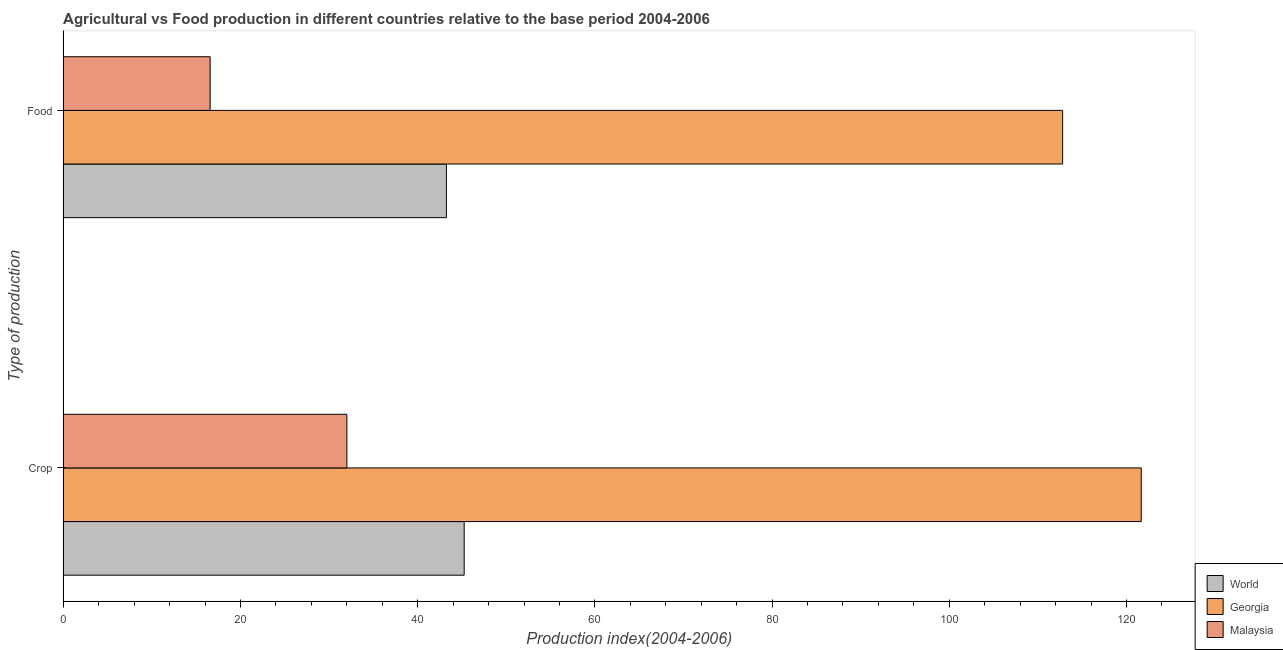Are the number of bars on each tick of the Y-axis equal?
Keep it short and to the point. Yes. How many bars are there on the 2nd tick from the top?
Your answer should be compact. 3. What is the label of the 1st group of bars from the top?
Ensure brevity in your answer.  Food. What is the crop production index in Georgia?
Keep it short and to the point. 121.66. Across all countries, what is the maximum crop production index?
Ensure brevity in your answer.  121.66. Across all countries, what is the minimum food production index?
Offer a very short reply. 16.58. In which country was the food production index maximum?
Provide a succinct answer. Georgia. In which country was the crop production index minimum?
Provide a succinct answer. Malaysia. What is the total crop production index in the graph?
Ensure brevity in your answer.  198.92. What is the difference between the crop production index in Georgia and that in Malaysia?
Your answer should be very brief. 89.65. What is the difference between the food production index in World and the crop production index in Georgia?
Offer a very short reply. -78.42. What is the average food production index per country?
Provide a succinct answer. 57.54. What is the difference between the food production index and crop production index in World?
Make the answer very short. -2.01. What is the ratio of the food production index in Georgia to that in Malaysia?
Offer a terse response. 6.8. In how many countries, is the food production index greater than the average food production index taken over all countries?
Your response must be concise. 1. What does the 1st bar from the top in Food represents?
Give a very brief answer. Malaysia. What does the 3rd bar from the bottom in Food represents?
Provide a short and direct response. Malaysia. How many bars are there?
Offer a very short reply. 6. Are all the bars in the graph horizontal?
Your answer should be compact. Yes. Are the values on the major ticks of X-axis written in scientific E-notation?
Give a very brief answer. No. Does the graph contain grids?
Provide a succinct answer. No. Where does the legend appear in the graph?
Your response must be concise. Bottom right. How many legend labels are there?
Provide a short and direct response. 3. What is the title of the graph?
Ensure brevity in your answer.  Agricultural vs Food production in different countries relative to the base period 2004-2006. What is the label or title of the X-axis?
Keep it short and to the point. Production index(2004-2006). What is the label or title of the Y-axis?
Provide a short and direct response. Type of production. What is the Production index(2004-2006) of World in Crop?
Provide a short and direct response. 45.25. What is the Production index(2004-2006) of Georgia in Crop?
Offer a very short reply. 121.66. What is the Production index(2004-2006) in Malaysia in Crop?
Keep it short and to the point. 32.01. What is the Production index(2004-2006) in World in Food?
Offer a terse response. 43.24. What is the Production index(2004-2006) of Georgia in Food?
Make the answer very short. 112.79. What is the Production index(2004-2006) of Malaysia in Food?
Your answer should be compact. 16.58. Across all Type of production, what is the maximum Production index(2004-2006) in World?
Provide a succinct answer. 45.25. Across all Type of production, what is the maximum Production index(2004-2006) in Georgia?
Your answer should be very brief. 121.66. Across all Type of production, what is the maximum Production index(2004-2006) in Malaysia?
Provide a succinct answer. 32.01. Across all Type of production, what is the minimum Production index(2004-2006) in World?
Your response must be concise. 43.24. Across all Type of production, what is the minimum Production index(2004-2006) in Georgia?
Give a very brief answer. 112.79. Across all Type of production, what is the minimum Production index(2004-2006) of Malaysia?
Give a very brief answer. 16.58. What is the total Production index(2004-2006) of World in the graph?
Make the answer very short. 88.49. What is the total Production index(2004-2006) of Georgia in the graph?
Your answer should be very brief. 234.45. What is the total Production index(2004-2006) in Malaysia in the graph?
Your answer should be compact. 48.59. What is the difference between the Production index(2004-2006) in World in Crop and that in Food?
Ensure brevity in your answer.  2.01. What is the difference between the Production index(2004-2006) in Georgia in Crop and that in Food?
Your answer should be very brief. 8.87. What is the difference between the Production index(2004-2006) in Malaysia in Crop and that in Food?
Provide a succinct answer. 15.43. What is the difference between the Production index(2004-2006) of World in Crop and the Production index(2004-2006) of Georgia in Food?
Provide a short and direct response. -67.54. What is the difference between the Production index(2004-2006) of World in Crop and the Production index(2004-2006) of Malaysia in Food?
Offer a terse response. 28.67. What is the difference between the Production index(2004-2006) in Georgia in Crop and the Production index(2004-2006) in Malaysia in Food?
Make the answer very short. 105.08. What is the average Production index(2004-2006) in World per Type of production?
Your answer should be very brief. 44.25. What is the average Production index(2004-2006) in Georgia per Type of production?
Provide a short and direct response. 117.22. What is the average Production index(2004-2006) of Malaysia per Type of production?
Your answer should be compact. 24.3. What is the difference between the Production index(2004-2006) of World and Production index(2004-2006) of Georgia in Crop?
Ensure brevity in your answer.  -76.41. What is the difference between the Production index(2004-2006) of World and Production index(2004-2006) of Malaysia in Crop?
Your answer should be compact. 13.24. What is the difference between the Production index(2004-2006) in Georgia and Production index(2004-2006) in Malaysia in Crop?
Ensure brevity in your answer.  89.65. What is the difference between the Production index(2004-2006) in World and Production index(2004-2006) in Georgia in Food?
Your answer should be compact. -69.55. What is the difference between the Production index(2004-2006) in World and Production index(2004-2006) in Malaysia in Food?
Offer a terse response. 26.66. What is the difference between the Production index(2004-2006) of Georgia and Production index(2004-2006) of Malaysia in Food?
Your answer should be very brief. 96.21. What is the ratio of the Production index(2004-2006) of World in Crop to that in Food?
Your answer should be very brief. 1.05. What is the ratio of the Production index(2004-2006) of Georgia in Crop to that in Food?
Keep it short and to the point. 1.08. What is the ratio of the Production index(2004-2006) in Malaysia in Crop to that in Food?
Your response must be concise. 1.93. What is the difference between the highest and the second highest Production index(2004-2006) in World?
Offer a terse response. 2.01. What is the difference between the highest and the second highest Production index(2004-2006) of Georgia?
Your response must be concise. 8.87. What is the difference between the highest and the second highest Production index(2004-2006) in Malaysia?
Make the answer very short. 15.43. What is the difference between the highest and the lowest Production index(2004-2006) in World?
Your response must be concise. 2.01. What is the difference between the highest and the lowest Production index(2004-2006) of Georgia?
Your response must be concise. 8.87. What is the difference between the highest and the lowest Production index(2004-2006) of Malaysia?
Your answer should be compact. 15.43. 